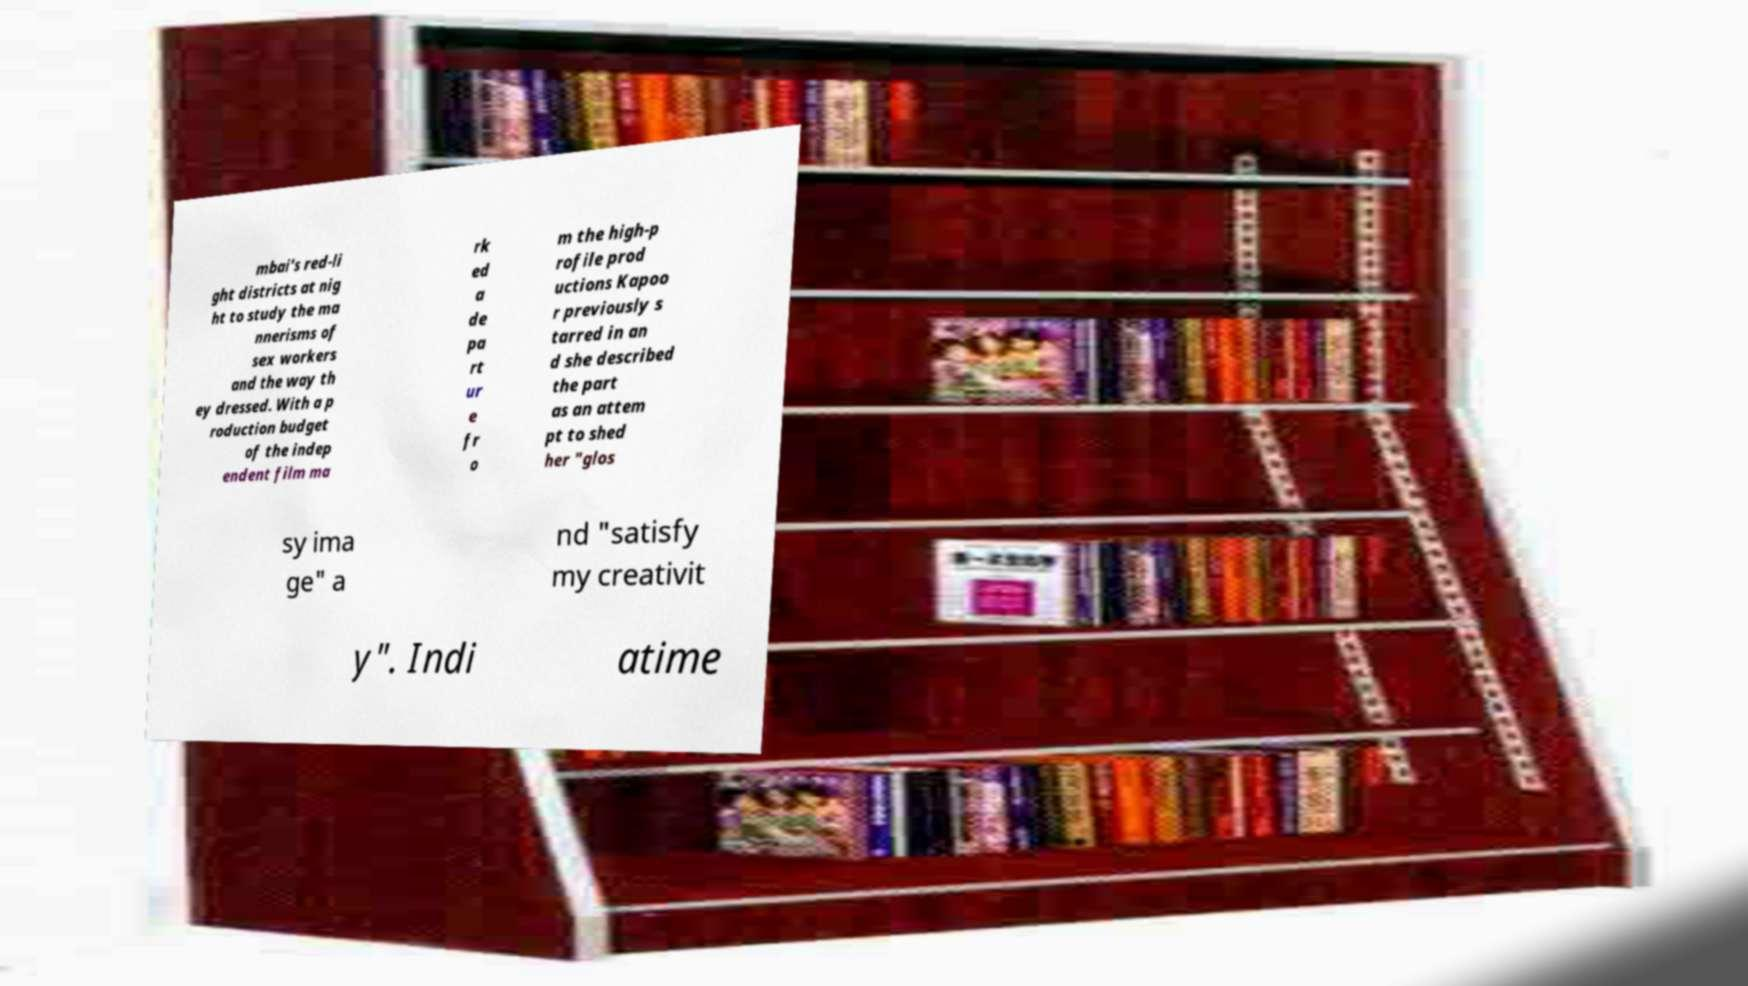Could you extract and type out the text from this image? mbai's red-li ght districts at nig ht to study the ma nnerisms of sex workers and the way th ey dressed. With a p roduction budget of the indep endent film ma rk ed a de pa rt ur e fr o m the high-p rofile prod uctions Kapoo r previously s tarred in an d she described the part as an attem pt to shed her "glos sy ima ge" a nd "satisfy my creativit y". Indi atime 